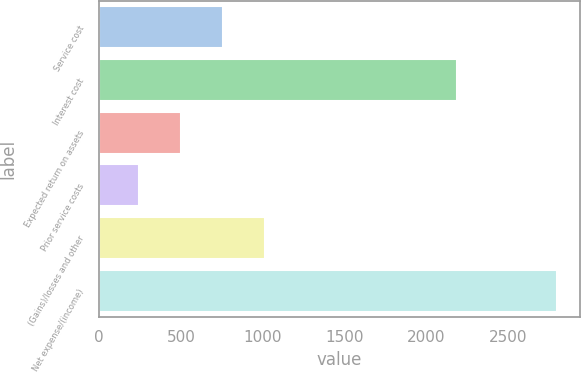Convert chart to OTSL. <chart><loc_0><loc_0><loc_500><loc_500><bar_chart><fcel>Service cost<fcel>Interest cost<fcel>Expected return on assets<fcel>Prior service costs<fcel>(Gains)/losses and other<fcel>Net expense/(income)<nl><fcel>756.2<fcel>2188<fcel>500.6<fcel>245<fcel>1011.8<fcel>2801<nl></chart> 